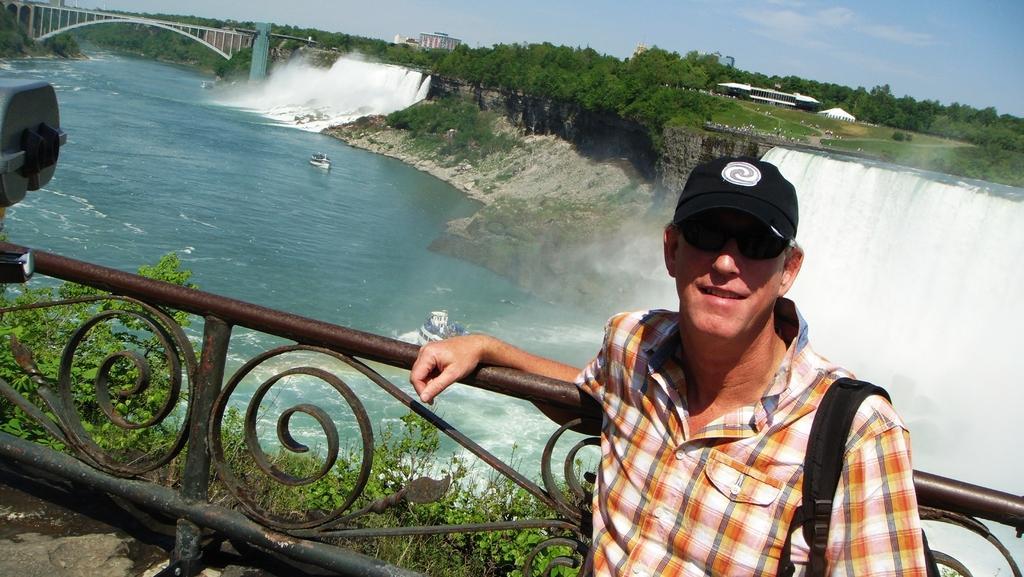Describe this image in one or two sentences. In this image on the right there is a man wearing checked shirt, sunglasses, cap is standing with a smiling face. He is carrying a bag. This is metal railing. In the background there are waterfalls. On the water body there are boats. This is a bridge. In the background there are trees, buildings. The sky is cloudy. Here there are plants. 